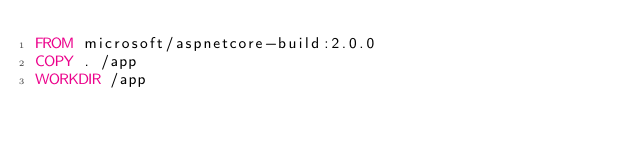Convert code to text. <code><loc_0><loc_0><loc_500><loc_500><_Dockerfile_>FROM microsoft/aspnetcore-build:2.0.0
COPY . /app
WORKDIR /app

</code> 